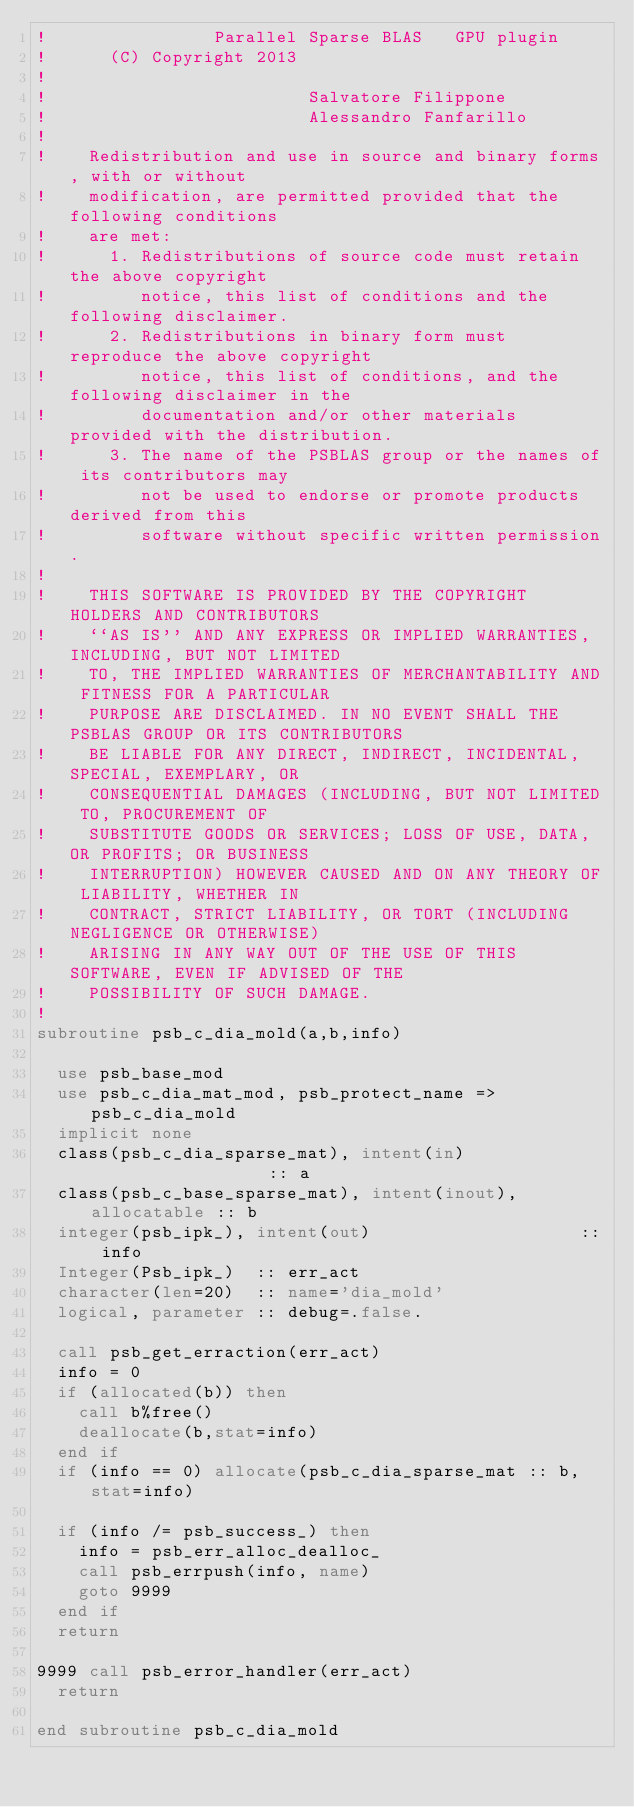Convert code to text. <code><loc_0><loc_0><loc_500><loc_500><_FORTRAN_>!                Parallel Sparse BLAS   GPU plugin 
!      (C) Copyright 2013
!  
!                         Salvatore Filippone
!                         Alessandro Fanfarillo
!   
!    Redistribution and use in source and binary forms, with or without
!    modification, are permitted provided that the following conditions
!    are met:
!      1. Redistributions of source code must retain the above copyright
!         notice, this list of conditions and the following disclaimer.
!      2. Redistributions in binary form must reproduce the above copyright
!         notice, this list of conditions, and the following disclaimer in the
!         documentation and/or other materials provided with the distribution.
!      3. The name of the PSBLAS group or the names of its contributors may
!         not be used to endorse or promote products derived from this
!         software without specific written permission.
!   
!    THIS SOFTWARE IS PROVIDED BY THE COPYRIGHT HOLDERS AND CONTRIBUTORS
!    ``AS IS'' AND ANY EXPRESS OR IMPLIED WARRANTIES, INCLUDING, BUT NOT LIMITED
!    TO, THE IMPLIED WARRANTIES OF MERCHANTABILITY AND FITNESS FOR A PARTICULAR
!    PURPOSE ARE DISCLAIMED. IN NO EVENT SHALL THE PSBLAS GROUP OR ITS CONTRIBUTORS
!    BE LIABLE FOR ANY DIRECT, INDIRECT, INCIDENTAL, SPECIAL, EXEMPLARY, OR
!    CONSEQUENTIAL DAMAGES (INCLUDING, BUT NOT LIMITED TO, PROCUREMENT OF
!    SUBSTITUTE GOODS OR SERVICES; LOSS OF USE, DATA, OR PROFITS; OR BUSINESS
!    INTERRUPTION) HOWEVER CAUSED AND ON ANY THEORY OF LIABILITY, WHETHER IN
!    CONTRACT, STRICT LIABILITY, OR TORT (INCLUDING NEGLIGENCE OR OTHERWISE)
!    ARISING IN ANY WAY OUT OF THE USE OF THIS SOFTWARE, EVEN IF ADVISED OF THE
!    POSSIBILITY OF SUCH DAMAGE.
!   
subroutine psb_c_dia_mold(a,b,info) 
  
  use psb_base_mod
  use psb_c_dia_mat_mod, psb_protect_name => psb_c_dia_mold
  implicit none 
  class(psb_c_dia_sparse_mat), intent(in)                  :: a
  class(psb_c_base_sparse_mat), intent(inout), allocatable :: b
  integer(psb_ipk_), intent(out)                    :: info
  Integer(Psb_ipk_)  :: err_act
  character(len=20)  :: name='dia_mold'
  logical, parameter :: debug=.false.

  call psb_get_erraction(err_act)
  info = 0 
  if (allocated(b)) then 
    call b%free()
    deallocate(b,stat=info)
  end if
  if (info == 0) allocate(psb_c_dia_sparse_mat :: b, stat=info)

  if (info /= psb_success_) then 
    info = psb_err_alloc_dealloc_ 
    call psb_errpush(info, name)
    goto 9999
  end if
  return

9999 call psb_error_handler(err_act)
  return

end subroutine psb_c_dia_mold
</code> 